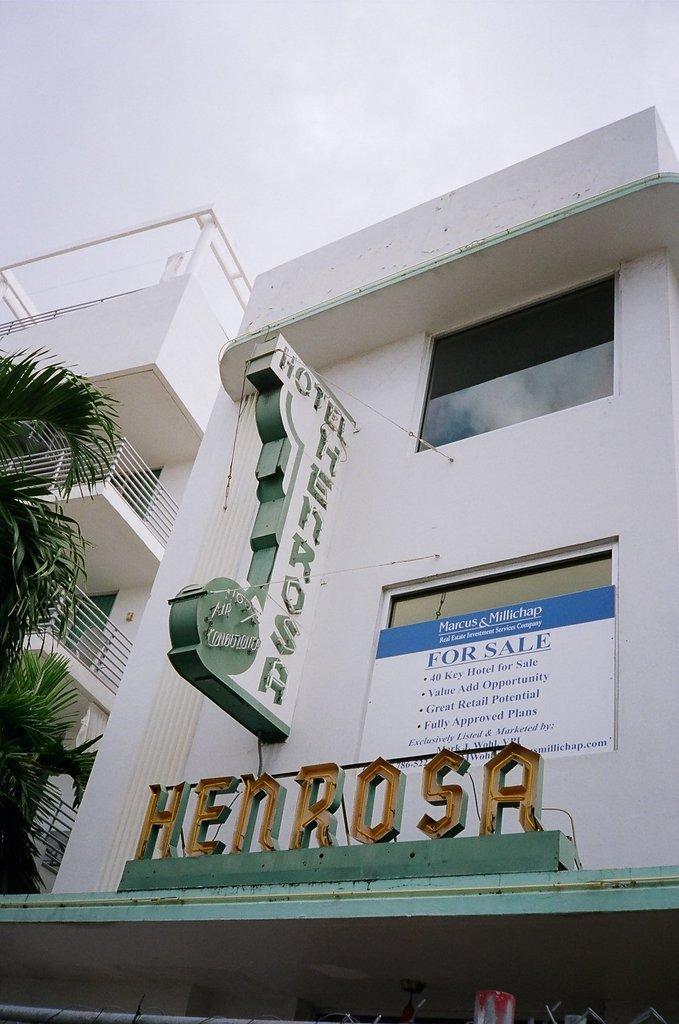Please provide a concise description of this image. In this image I can see white color building and on it I can see few boards. On these words I can see something is written and here I can also see a tree. 